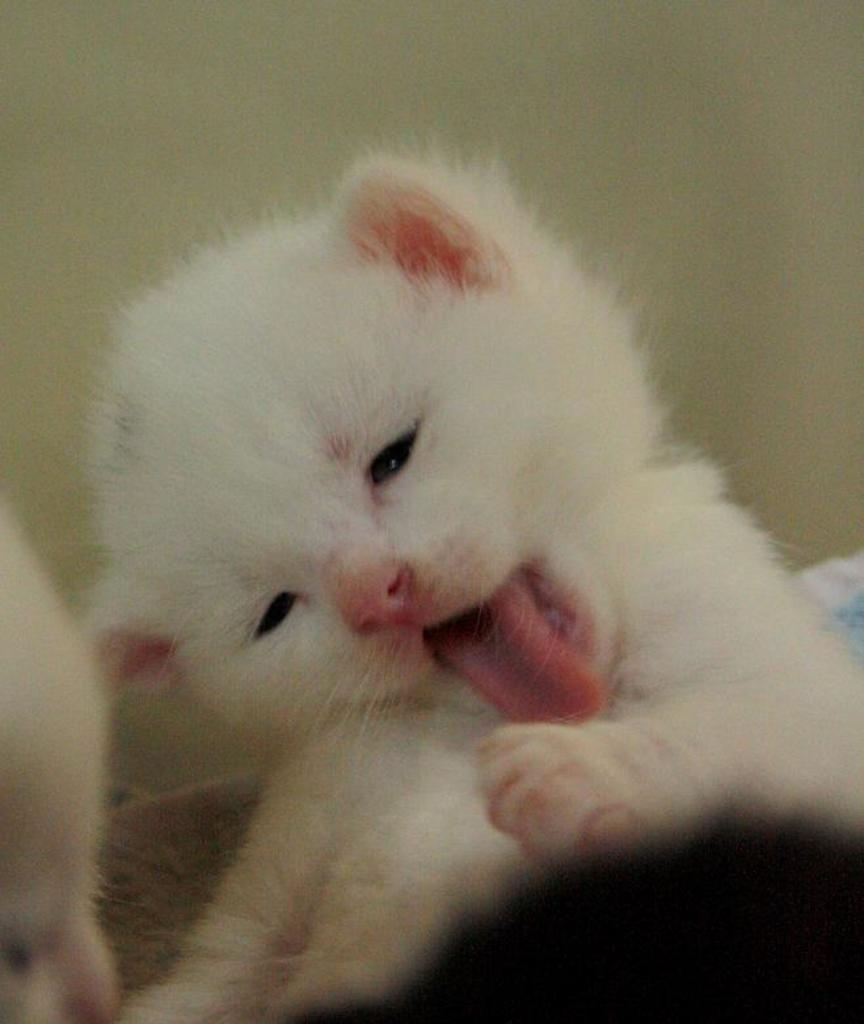What type of animal is in the image? There is a cat in the image. What color is the cat? The cat is white in color. What is the cat doing in the image? The cat is yawning. What type of boot is the cat wearing in the image? There is no boot present in the image; the cat is not wearing any footwear. 